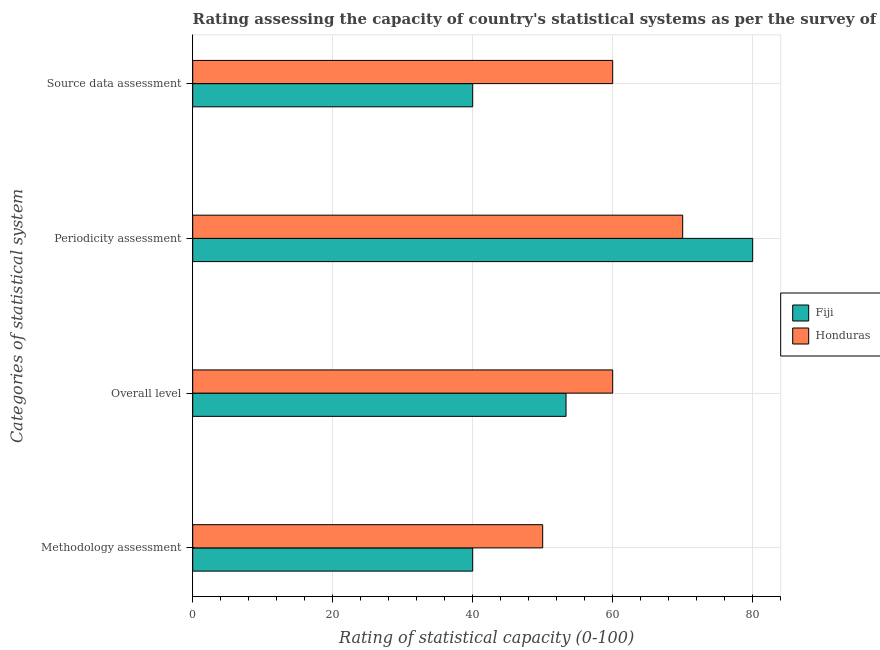How many different coloured bars are there?
Your answer should be compact. 2. How many groups of bars are there?
Ensure brevity in your answer.  4. How many bars are there on the 2nd tick from the top?
Keep it short and to the point. 2. How many bars are there on the 2nd tick from the bottom?
Keep it short and to the point. 2. What is the label of the 2nd group of bars from the top?
Ensure brevity in your answer.  Periodicity assessment. Across all countries, what is the maximum methodology assessment rating?
Provide a succinct answer. 50. In which country was the methodology assessment rating maximum?
Your answer should be compact. Honduras. In which country was the periodicity assessment rating minimum?
Give a very brief answer. Honduras. What is the total overall level rating in the graph?
Your response must be concise. 113.33. What is the average methodology assessment rating per country?
Ensure brevity in your answer.  45. What is the difference between the source data assessment rating and periodicity assessment rating in Honduras?
Ensure brevity in your answer.  -10. What is the ratio of the overall level rating in Fiji to that in Honduras?
Provide a succinct answer. 0.89. Is the difference between the overall level rating in Honduras and Fiji greater than the difference between the methodology assessment rating in Honduras and Fiji?
Provide a short and direct response. No. What is the difference between the highest and the second highest overall level rating?
Offer a terse response. 6.67. What is the difference between the highest and the lowest source data assessment rating?
Your answer should be very brief. 20. Is the sum of the periodicity assessment rating in Honduras and Fiji greater than the maximum source data assessment rating across all countries?
Your response must be concise. Yes. Is it the case that in every country, the sum of the periodicity assessment rating and overall level rating is greater than the sum of methodology assessment rating and source data assessment rating?
Your answer should be very brief. Yes. What does the 1st bar from the top in Overall level represents?
Ensure brevity in your answer.  Honduras. What does the 1st bar from the bottom in Source data assessment represents?
Your answer should be compact. Fiji. Are all the bars in the graph horizontal?
Your answer should be very brief. Yes. How many countries are there in the graph?
Provide a succinct answer. 2. What is the difference between two consecutive major ticks on the X-axis?
Your response must be concise. 20. Are the values on the major ticks of X-axis written in scientific E-notation?
Your response must be concise. No. Does the graph contain any zero values?
Ensure brevity in your answer.  No. Does the graph contain grids?
Your answer should be very brief. Yes. Where does the legend appear in the graph?
Keep it short and to the point. Center right. How many legend labels are there?
Provide a short and direct response. 2. How are the legend labels stacked?
Provide a succinct answer. Vertical. What is the title of the graph?
Your response must be concise. Rating assessing the capacity of country's statistical systems as per the survey of 2005 . What is the label or title of the X-axis?
Your answer should be very brief. Rating of statistical capacity (0-100). What is the label or title of the Y-axis?
Provide a succinct answer. Categories of statistical system. What is the Rating of statistical capacity (0-100) of Fiji in Methodology assessment?
Provide a short and direct response. 40. What is the Rating of statistical capacity (0-100) of Fiji in Overall level?
Keep it short and to the point. 53.33. What is the Rating of statistical capacity (0-100) in Honduras in Overall level?
Offer a very short reply. 60. What is the Rating of statistical capacity (0-100) in Fiji in Periodicity assessment?
Your response must be concise. 80. What is the Rating of statistical capacity (0-100) of Honduras in Source data assessment?
Ensure brevity in your answer.  60. Across all Categories of statistical system, what is the maximum Rating of statistical capacity (0-100) of Fiji?
Give a very brief answer. 80. What is the total Rating of statistical capacity (0-100) of Fiji in the graph?
Ensure brevity in your answer.  213.33. What is the total Rating of statistical capacity (0-100) of Honduras in the graph?
Your answer should be compact. 240. What is the difference between the Rating of statistical capacity (0-100) in Fiji in Methodology assessment and that in Overall level?
Your answer should be compact. -13.33. What is the difference between the Rating of statistical capacity (0-100) of Honduras in Methodology assessment and that in Overall level?
Provide a succinct answer. -10. What is the difference between the Rating of statistical capacity (0-100) of Fiji in Methodology assessment and that in Periodicity assessment?
Ensure brevity in your answer.  -40. What is the difference between the Rating of statistical capacity (0-100) in Honduras in Methodology assessment and that in Periodicity assessment?
Make the answer very short. -20. What is the difference between the Rating of statistical capacity (0-100) in Fiji in Methodology assessment and that in Source data assessment?
Provide a short and direct response. 0. What is the difference between the Rating of statistical capacity (0-100) in Fiji in Overall level and that in Periodicity assessment?
Your response must be concise. -26.67. What is the difference between the Rating of statistical capacity (0-100) in Honduras in Overall level and that in Periodicity assessment?
Provide a short and direct response. -10. What is the difference between the Rating of statistical capacity (0-100) of Fiji in Overall level and that in Source data assessment?
Offer a very short reply. 13.33. What is the difference between the Rating of statistical capacity (0-100) of Honduras in Overall level and that in Source data assessment?
Offer a terse response. 0. What is the difference between the Rating of statistical capacity (0-100) of Fiji in Periodicity assessment and that in Source data assessment?
Offer a very short reply. 40. What is the difference between the Rating of statistical capacity (0-100) in Honduras in Periodicity assessment and that in Source data assessment?
Provide a succinct answer. 10. What is the difference between the Rating of statistical capacity (0-100) of Fiji in Methodology assessment and the Rating of statistical capacity (0-100) of Honduras in Overall level?
Keep it short and to the point. -20. What is the difference between the Rating of statistical capacity (0-100) of Fiji in Methodology assessment and the Rating of statistical capacity (0-100) of Honduras in Periodicity assessment?
Offer a terse response. -30. What is the difference between the Rating of statistical capacity (0-100) of Fiji in Overall level and the Rating of statistical capacity (0-100) of Honduras in Periodicity assessment?
Your response must be concise. -16.67. What is the difference between the Rating of statistical capacity (0-100) in Fiji in Overall level and the Rating of statistical capacity (0-100) in Honduras in Source data assessment?
Provide a short and direct response. -6.67. What is the difference between the Rating of statistical capacity (0-100) of Fiji in Periodicity assessment and the Rating of statistical capacity (0-100) of Honduras in Source data assessment?
Offer a very short reply. 20. What is the average Rating of statistical capacity (0-100) of Fiji per Categories of statistical system?
Offer a very short reply. 53.33. What is the average Rating of statistical capacity (0-100) in Honduras per Categories of statistical system?
Your answer should be very brief. 60. What is the difference between the Rating of statistical capacity (0-100) of Fiji and Rating of statistical capacity (0-100) of Honduras in Methodology assessment?
Your answer should be very brief. -10. What is the difference between the Rating of statistical capacity (0-100) in Fiji and Rating of statistical capacity (0-100) in Honduras in Overall level?
Ensure brevity in your answer.  -6.67. What is the difference between the Rating of statistical capacity (0-100) in Fiji and Rating of statistical capacity (0-100) in Honduras in Source data assessment?
Your answer should be very brief. -20. What is the ratio of the Rating of statistical capacity (0-100) in Honduras in Methodology assessment to that in Overall level?
Ensure brevity in your answer.  0.83. What is the ratio of the Rating of statistical capacity (0-100) in Fiji in Methodology assessment to that in Periodicity assessment?
Your answer should be compact. 0.5. What is the ratio of the Rating of statistical capacity (0-100) in Honduras in Methodology assessment to that in Periodicity assessment?
Offer a very short reply. 0.71. What is the ratio of the Rating of statistical capacity (0-100) of Fiji in Methodology assessment to that in Source data assessment?
Provide a succinct answer. 1. What is the ratio of the Rating of statistical capacity (0-100) in Honduras in Methodology assessment to that in Source data assessment?
Your answer should be compact. 0.83. What is the ratio of the Rating of statistical capacity (0-100) in Fiji in Overall level to that in Periodicity assessment?
Provide a succinct answer. 0.67. What is the ratio of the Rating of statistical capacity (0-100) of Honduras in Overall level to that in Periodicity assessment?
Provide a succinct answer. 0.86. What is the ratio of the Rating of statistical capacity (0-100) in Fiji in Periodicity assessment to that in Source data assessment?
Make the answer very short. 2. What is the difference between the highest and the second highest Rating of statistical capacity (0-100) in Fiji?
Give a very brief answer. 26.67. What is the difference between the highest and the second highest Rating of statistical capacity (0-100) of Honduras?
Make the answer very short. 10. What is the difference between the highest and the lowest Rating of statistical capacity (0-100) of Fiji?
Provide a short and direct response. 40. What is the difference between the highest and the lowest Rating of statistical capacity (0-100) in Honduras?
Give a very brief answer. 20. 